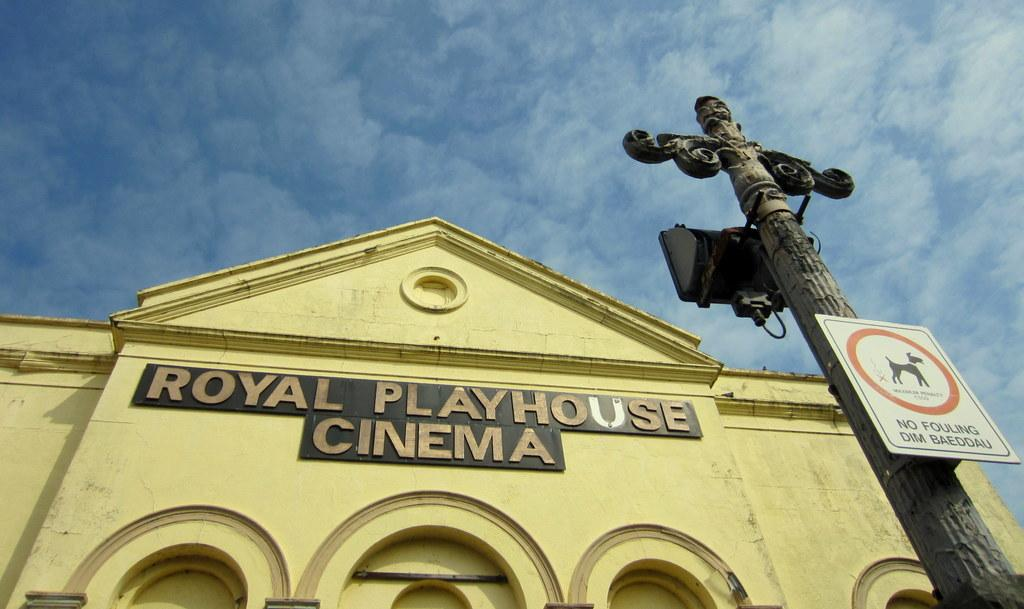What type of structure is visible in the image? There is a building in the image. What else can be seen besides the building? There is a pole and a hoarding in the image. What is the condition of the sky in the image? The sky is clear in the image. What is the weather like in the image? It is sunny in the image. What shape is the question in the image? There is no question present in the image, so it cannot be determined what shape it might have. 